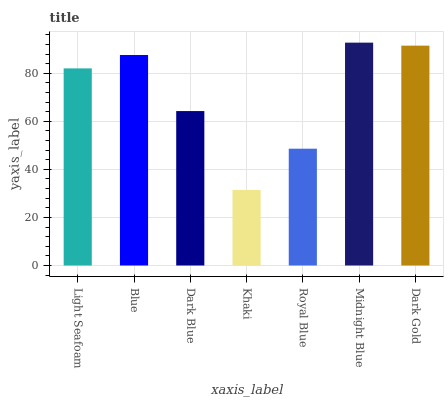Is Khaki the minimum?
Answer yes or no. Yes. Is Midnight Blue the maximum?
Answer yes or no. Yes. Is Blue the minimum?
Answer yes or no. No. Is Blue the maximum?
Answer yes or no. No. Is Blue greater than Light Seafoam?
Answer yes or no. Yes. Is Light Seafoam less than Blue?
Answer yes or no. Yes. Is Light Seafoam greater than Blue?
Answer yes or no. No. Is Blue less than Light Seafoam?
Answer yes or no. No. Is Light Seafoam the high median?
Answer yes or no. Yes. Is Light Seafoam the low median?
Answer yes or no. Yes. Is Dark Blue the high median?
Answer yes or no. No. Is Khaki the low median?
Answer yes or no. No. 